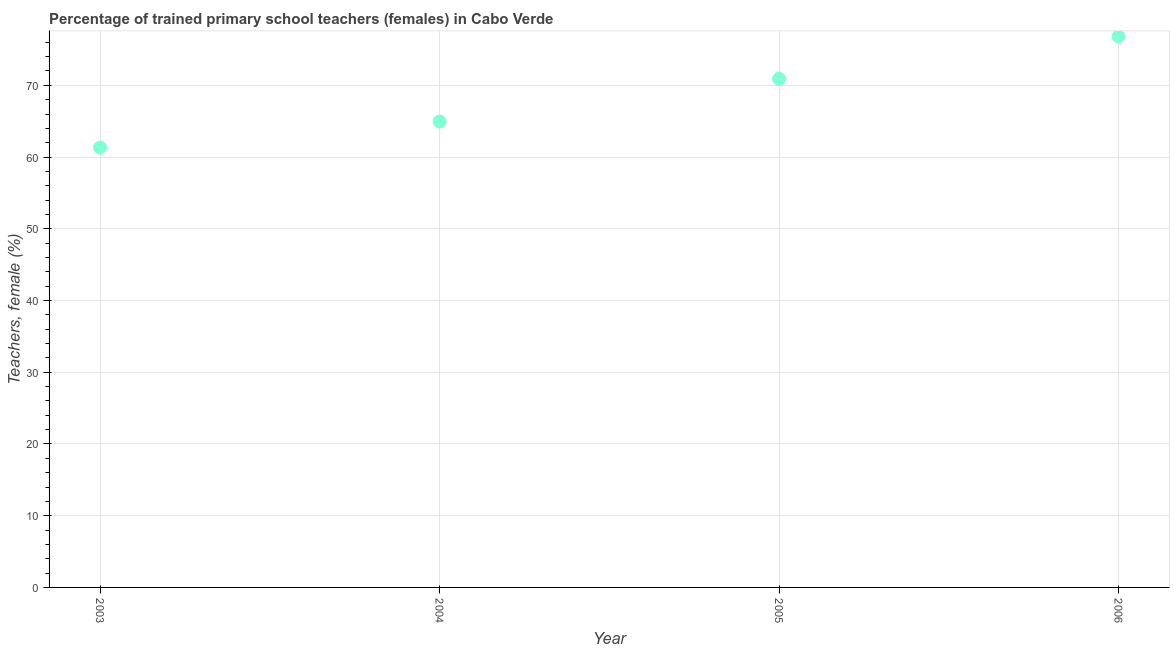What is the percentage of trained female teachers in 2004?
Your answer should be very brief. 64.96. Across all years, what is the maximum percentage of trained female teachers?
Give a very brief answer. 76.82. Across all years, what is the minimum percentage of trained female teachers?
Provide a succinct answer. 61.33. In which year was the percentage of trained female teachers minimum?
Offer a very short reply. 2003. What is the sum of the percentage of trained female teachers?
Provide a succinct answer. 274.03. What is the difference between the percentage of trained female teachers in 2005 and 2006?
Your response must be concise. -5.91. What is the average percentage of trained female teachers per year?
Your answer should be compact. 68.51. What is the median percentage of trained female teachers?
Give a very brief answer. 67.94. In how many years, is the percentage of trained female teachers greater than 66 %?
Offer a very short reply. 2. Do a majority of the years between 2003 and 2006 (inclusive) have percentage of trained female teachers greater than 22 %?
Provide a short and direct response. Yes. What is the ratio of the percentage of trained female teachers in 2004 to that in 2005?
Keep it short and to the point. 0.92. What is the difference between the highest and the second highest percentage of trained female teachers?
Ensure brevity in your answer.  5.91. What is the difference between the highest and the lowest percentage of trained female teachers?
Offer a terse response. 15.5. In how many years, is the percentage of trained female teachers greater than the average percentage of trained female teachers taken over all years?
Your answer should be compact. 2. Does the percentage of trained female teachers monotonically increase over the years?
Provide a short and direct response. Yes. How many dotlines are there?
Provide a succinct answer. 1. Are the values on the major ticks of Y-axis written in scientific E-notation?
Your answer should be compact. No. Does the graph contain any zero values?
Your answer should be very brief. No. What is the title of the graph?
Give a very brief answer. Percentage of trained primary school teachers (females) in Cabo Verde. What is the label or title of the Y-axis?
Provide a succinct answer. Teachers, female (%). What is the Teachers, female (%) in 2003?
Ensure brevity in your answer.  61.33. What is the Teachers, female (%) in 2004?
Keep it short and to the point. 64.96. What is the Teachers, female (%) in 2005?
Make the answer very short. 70.91. What is the Teachers, female (%) in 2006?
Keep it short and to the point. 76.82. What is the difference between the Teachers, female (%) in 2003 and 2004?
Offer a very short reply. -3.63. What is the difference between the Teachers, female (%) in 2003 and 2005?
Keep it short and to the point. -9.59. What is the difference between the Teachers, female (%) in 2003 and 2006?
Ensure brevity in your answer.  -15.5. What is the difference between the Teachers, female (%) in 2004 and 2005?
Provide a short and direct response. -5.95. What is the difference between the Teachers, female (%) in 2004 and 2006?
Make the answer very short. -11.86. What is the difference between the Teachers, female (%) in 2005 and 2006?
Offer a terse response. -5.91. What is the ratio of the Teachers, female (%) in 2003 to that in 2004?
Offer a terse response. 0.94. What is the ratio of the Teachers, female (%) in 2003 to that in 2005?
Provide a short and direct response. 0.86. What is the ratio of the Teachers, female (%) in 2003 to that in 2006?
Keep it short and to the point. 0.8. What is the ratio of the Teachers, female (%) in 2004 to that in 2005?
Give a very brief answer. 0.92. What is the ratio of the Teachers, female (%) in 2004 to that in 2006?
Your answer should be very brief. 0.85. What is the ratio of the Teachers, female (%) in 2005 to that in 2006?
Your answer should be compact. 0.92. 